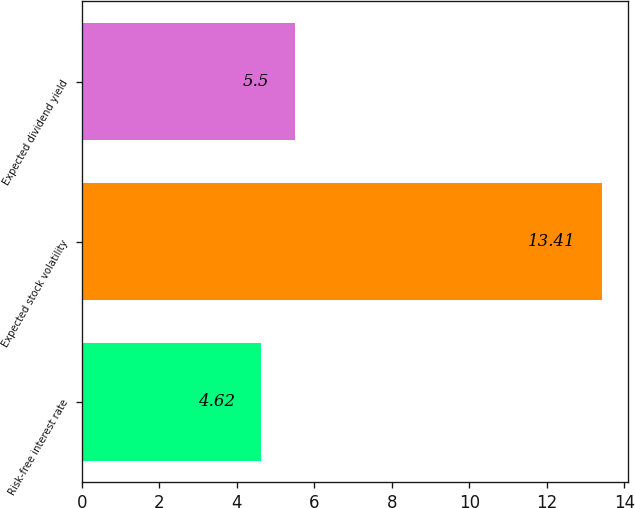Convert chart to OTSL. <chart><loc_0><loc_0><loc_500><loc_500><bar_chart><fcel>Risk-free interest rate<fcel>Expected stock volatility<fcel>Expected dividend yield<nl><fcel>4.62<fcel>13.41<fcel>5.5<nl></chart> 